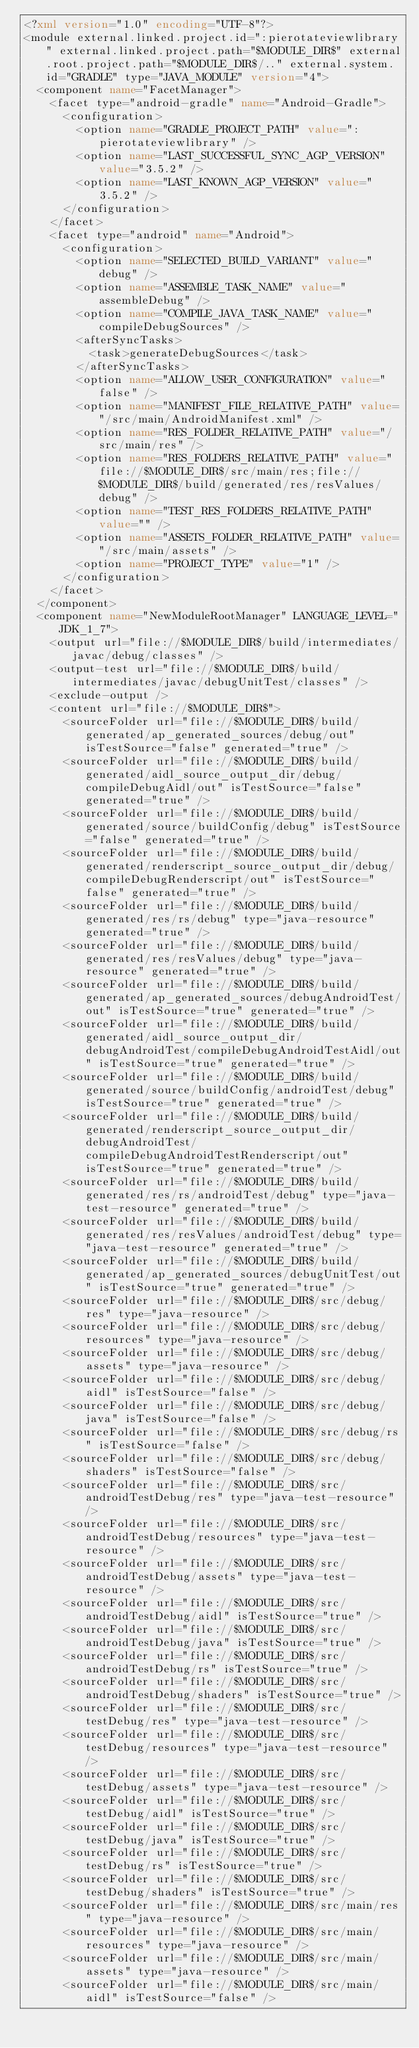<code> <loc_0><loc_0><loc_500><loc_500><_XML_><?xml version="1.0" encoding="UTF-8"?>
<module external.linked.project.id=":pierotateviewlibrary" external.linked.project.path="$MODULE_DIR$" external.root.project.path="$MODULE_DIR$/.." external.system.id="GRADLE" type="JAVA_MODULE" version="4">
  <component name="FacetManager">
    <facet type="android-gradle" name="Android-Gradle">
      <configuration>
        <option name="GRADLE_PROJECT_PATH" value=":pierotateviewlibrary" />
        <option name="LAST_SUCCESSFUL_SYNC_AGP_VERSION" value="3.5.2" />
        <option name="LAST_KNOWN_AGP_VERSION" value="3.5.2" />
      </configuration>
    </facet>
    <facet type="android" name="Android">
      <configuration>
        <option name="SELECTED_BUILD_VARIANT" value="debug" />
        <option name="ASSEMBLE_TASK_NAME" value="assembleDebug" />
        <option name="COMPILE_JAVA_TASK_NAME" value="compileDebugSources" />
        <afterSyncTasks>
          <task>generateDebugSources</task>
        </afterSyncTasks>
        <option name="ALLOW_USER_CONFIGURATION" value="false" />
        <option name="MANIFEST_FILE_RELATIVE_PATH" value="/src/main/AndroidManifest.xml" />
        <option name="RES_FOLDER_RELATIVE_PATH" value="/src/main/res" />
        <option name="RES_FOLDERS_RELATIVE_PATH" value="file://$MODULE_DIR$/src/main/res;file://$MODULE_DIR$/build/generated/res/resValues/debug" />
        <option name="TEST_RES_FOLDERS_RELATIVE_PATH" value="" />
        <option name="ASSETS_FOLDER_RELATIVE_PATH" value="/src/main/assets" />
        <option name="PROJECT_TYPE" value="1" />
      </configuration>
    </facet>
  </component>
  <component name="NewModuleRootManager" LANGUAGE_LEVEL="JDK_1_7">
    <output url="file://$MODULE_DIR$/build/intermediates/javac/debug/classes" />
    <output-test url="file://$MODULE_DIR$/build/intermediates/javac/debugUnitTest/classes" />
    <exclude-output />
    <content url="file://$MODULE_DIR$">
      <sourceFolder url="file://$MODULE_DIR$/build/generated/ap_generated_sources/debug/out" isTestSource="false" generated="true" />
      <sourceFolder url="file://$MODULE_DIR$/build/generated/aidl_source_output_dir/debug/compileDebugAidl/out" isTestSource="false" generated="true" />
      <sourceFolder url="file://$MODULE_DIR$/build/generated/source/buildConfig/debug" isTestSource="false" generated="true" />
      <sourceFolder url="file://$MODULE_DIR$/build/generated/renderscript_source_output_dir/debug/compileDebugRenderscript/out" isTestSource="false" generated="true" />
      <sourceFolder url="file://$MODULE_DIR$/build/generated/res/rs/debug" type="java-resource" generated="true" />
      <sourceFolder url="file://$MODULE_DIR$/build/generated/res/resValues/debug" type="java-resource" generated="true" />
      <sourceFolder url="file://$MODULE_DIR$/build/generated/ap_generated_sources/debugAndroidTest/out" isTestSource="true" generated="true" />
      <sourceFolder url="file://$MODULE_DIR$/build/generated/aidl_source_output_dir/debugAndroidTest/compileDebugAndroidTestAidl/out" isTestSource="true" generated="true" />
      <sourceFolder url="file://$MODULE_DIR$/build/generated/source/buildConfig/androidTest/debug" isTestSource="true" generated="true" />
      <sourceFolder url="file://$MODULE_DIR$/build/generated/renderscript_source_output_dir/debugAndroidTest/compileDebugAndroidTestRenderscript/out" isTestSource="true" generated="true" />
      <sourceFolder url="file://$MODULE_DIR$/build/generated/res/rs/androidTest/debug" type="java-test-resource" generated="true" />
      <sourceFolder url="file://$MODULE_DIR$/build/generated/res/resValues/androidTest/debug" type="java-test-resource" generated="true" />
      <sourceFolder url="file://$MODULE_DIR$/build/generated/ap_generated_sources/debugUnitTest/out" isTestSource="true" generated="true" />
      <sourceFolder url="file://$MODULE_DIR$/src/debug/res" type="java-resource" />
      <sourceFolder url="file://$MODULE_DIR$/src/debug/resources" type="java-resource" />
      <sourceFolder url="file://$MODULE_DIR$/src/debug/assets" type="java-resource" />
      <sourceFolder url="file://$MODULE_DIR$/src/debug/aidl" isTestSource="false" />
      <sourceFolder url="file://$MODULE_DIR$/src/debug/java" isTestSource="false" />
      <sourceFolder url="file://$MODULE_DIR$/src/debug/rs" isTestSource="false" />
      <sourceFolder url="file://$MODULE_DIR$/src/debug/shaders" isTestSource="false" />
      <sourceFolder url="file://$MODULE_DIR$/src/androidTestDebug/res" type="java-test-resource" />
      <sourceFolder url="file://$MODULE_DIR$/src/androidTestDebug/resources" type="java-test-resource" />
      <sourceFolder url="file://$MODULE_DIR$/src/androidTestDebug/assets" type="java-test-resource" />
      <sourceFolder url="file://$MODULE_DIR$/src/androidTestDebug/aidl" isTestSource="true" />
      <sourceFolder url="file://$MODULE_DIR$/src/androidTestDebug/java" isTestSource="true" />
      <sourceFolder url="file://$MODULE_DIR$/src/androidTestDebug/rs" isTestSource="true" />
      <sourceFolder url="file://$MODULE_DIR$/src/androidTestDebug/shaders" isTestSource="true" />
      <sourceFolder url="file://$MODULE_DIR$/src/testDebug/res" type="java-test-resource" />
      <sourceFolder url="file://$MODULE_DIR$/src/testDebug/resources" type="java-test-resource" />
      <sourceFolder url="file://$MODULE_DIR$/src/testDebug/assets" type="java-test-resource" />
      <sourceFolder url="file://$MODULE_DIR$/src/testDebug/aidl" isTestSource="true" />
      <sourceFolder url="file://$MODULE_DIR$/src/testDebug/java" isTestSource="true" />
      <sourceFolder url="file://$MODULE_DIR$/src/testDebug/rs" isTestSource="true" />
      <sourceFolder url="file://$MODULE_DIR$/src/testDebug/shaders" isTestSource="true" />
      <sourceFolder url="file://$MODULE_DIR$/src/main/res" type="java-resource" />
      <sourceFolder url="file://$MODULE_DIR$/src/main/resources" type="java-resource" />
      <sourceFolder url="file://$MODULE_DIR$/src/main/assets" type="java-resource" />
      <sourceFolder url="file://$MODULE_DIR$/src/main/aidl" isTestSource="false" /></code> 